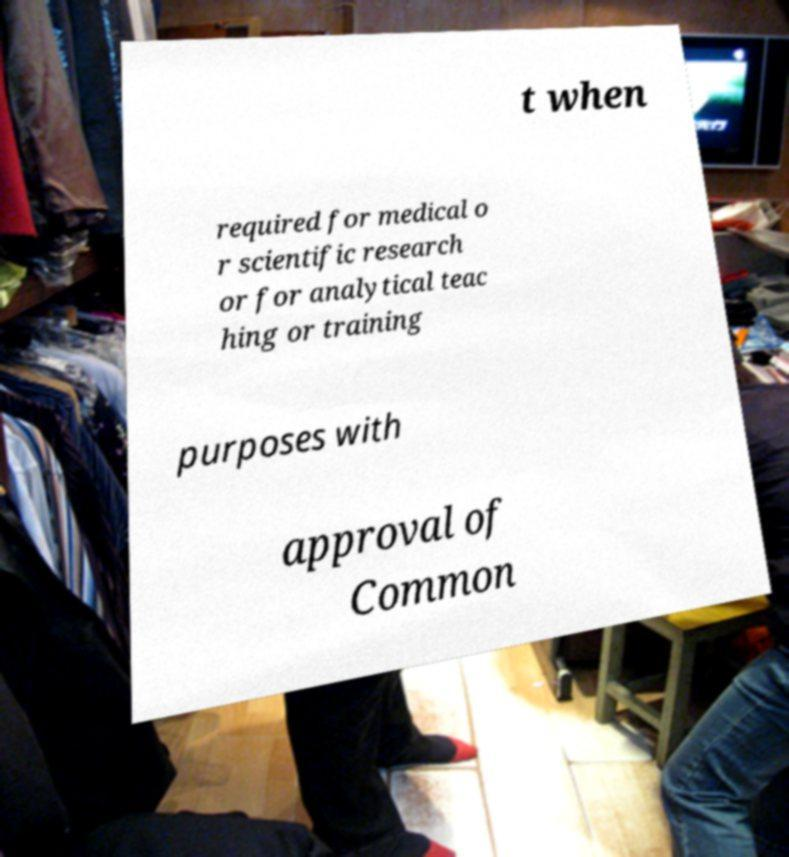Please identify and transcribe the text found in this image. t when required for medical o r scientific research or for analytical teac hing or training purposes with approval of Common 